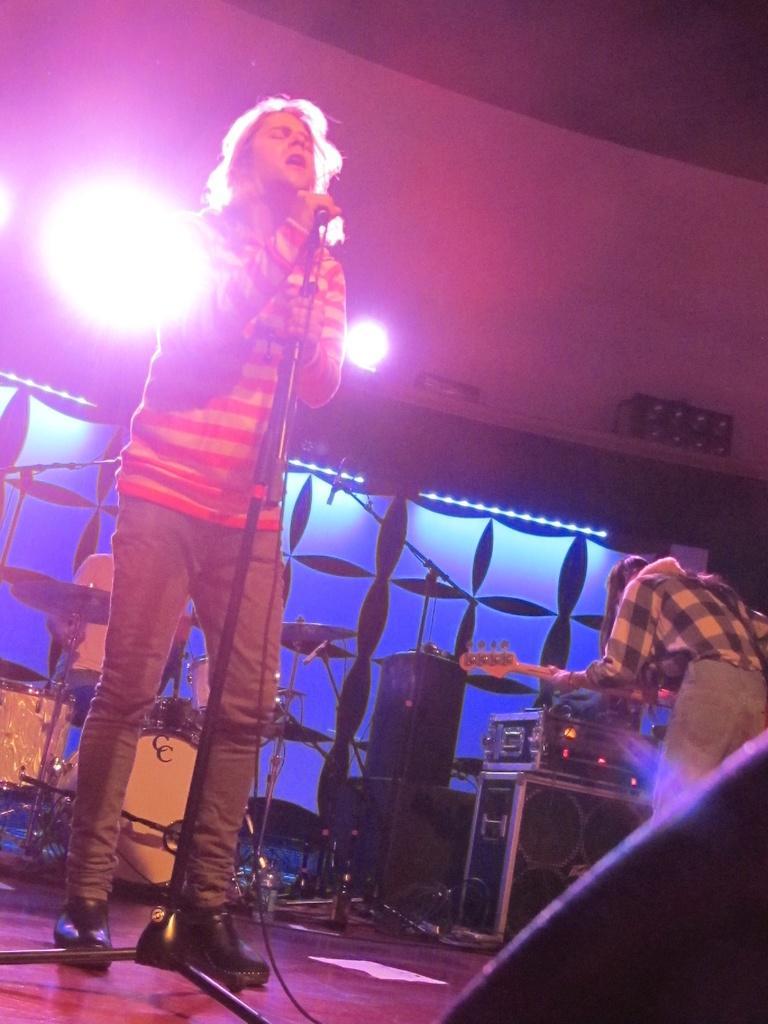Can you describe this image briefly? In this Image I see 3 persons in which one of them is holding a guitar and one of them is near drums and another one is holding a mic and he is standing. In the background I can see the lights and few equipment. 